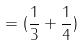Convert formula to latex. <formula><loc_0><loc_0><loc_500><loc_500>= ( \frac { 1 } { 3 } + \frac { 1 } { 4 } )</formula> 